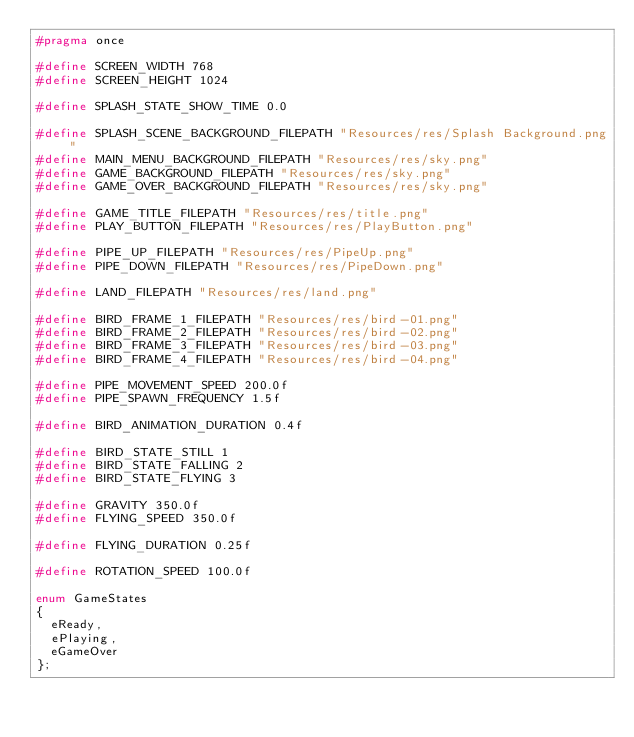<code> <loc_0><loc_0><loc_500><loc_500><_C++_>#pragma once

#define SCREEN_WIDTH 768
#define SCREEN_HEIGHT 1024

#define SPLASH_STATE_SHOW_TIME 0.0

#define SPLASH_SCENE_BACKGROUND_FILEPATH "Resources/res/Splash Background.png"
#define MAIN_MENU_BACKGROUND_FILEPATH "Resources/res/sky.png"
#define GAME_BACKGROUND_FILEPATH "Resources/res/sky.png"
#define GAME_OVER_BACKGROUND_FILEPATH "Resources/res/sky.png"

#define GAME_TITLE_FILEPATH "Resources/res/title.png"
#define PLAY_BUTTON_FILEPATH "Resources/res/PlayButton.png"

#define PIPE_UP_FILEPATH "Resources/res/PipeUp.png"
#define PIPE_DOWN_FILEPATH "Resources/res/PipeDown.png"

#define LAND_FILEPATH "Resources/res/land.png"

#define BIRD_FRAME_1_FILEPATH "Resources/res/bird-01.png"
#define BIRD_FRAME_2_FILEPATH "Resources/res/bird-02.png"
#define BIRD_FRAME_3_FILEPATH "Resources/res/bird-03.png"
#define BIRD_FRAME_4_FILEPATH "Resources/res/bird-04.png"

#define PIPE_MOVEMENT_SPEED 200.0f
#define PIPE_SPAWN_FREQUENCY 1.5f

#define BIRD_ANIMATION_DURATION 0.4f

#define BIRD_STATE_STILL 1
#define BIRD_STATE_FALLING 2
#define BIRD_STATE_FLYING 3

#define GRAVITY 350.0f
#define FLYING_SPEED 350.0f

#define FLYING_DURATION 0.25f

#define ROTATION_SPEED 100.0f

enum GameStates
{
	eReady,
	ePlaying,
	eGameOver
};</code> 